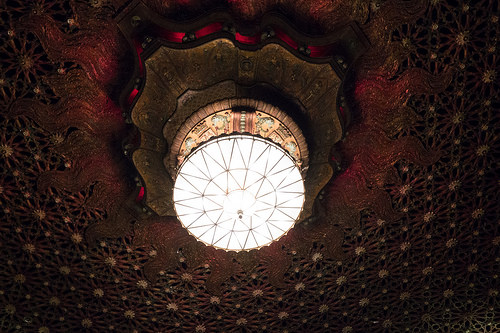<image>
Can you confirm if the light is under the frame? Yes. The light is positioned underneath the frame, with the frame above it in the vertical space. 